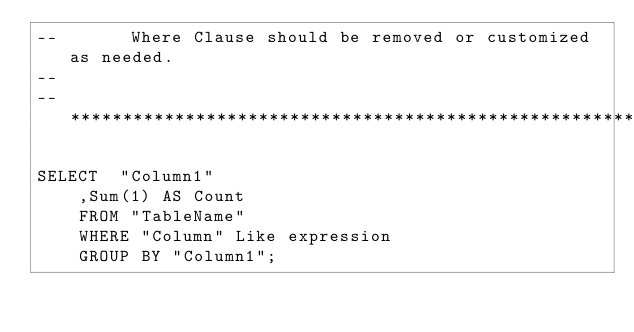Convert code to text. <code><loc_0><loc_0><loc_500><loc_500><_SQL_>--       Where Clause should be removed or customized as needed.
--
--***************************************************************************************************************************

SELECT 	"Column1"
	,Sum(1) AS Count
	FROM "TableName"
	WHERE "Column" Like expression
	GROUP BY "Column1";
</code> 